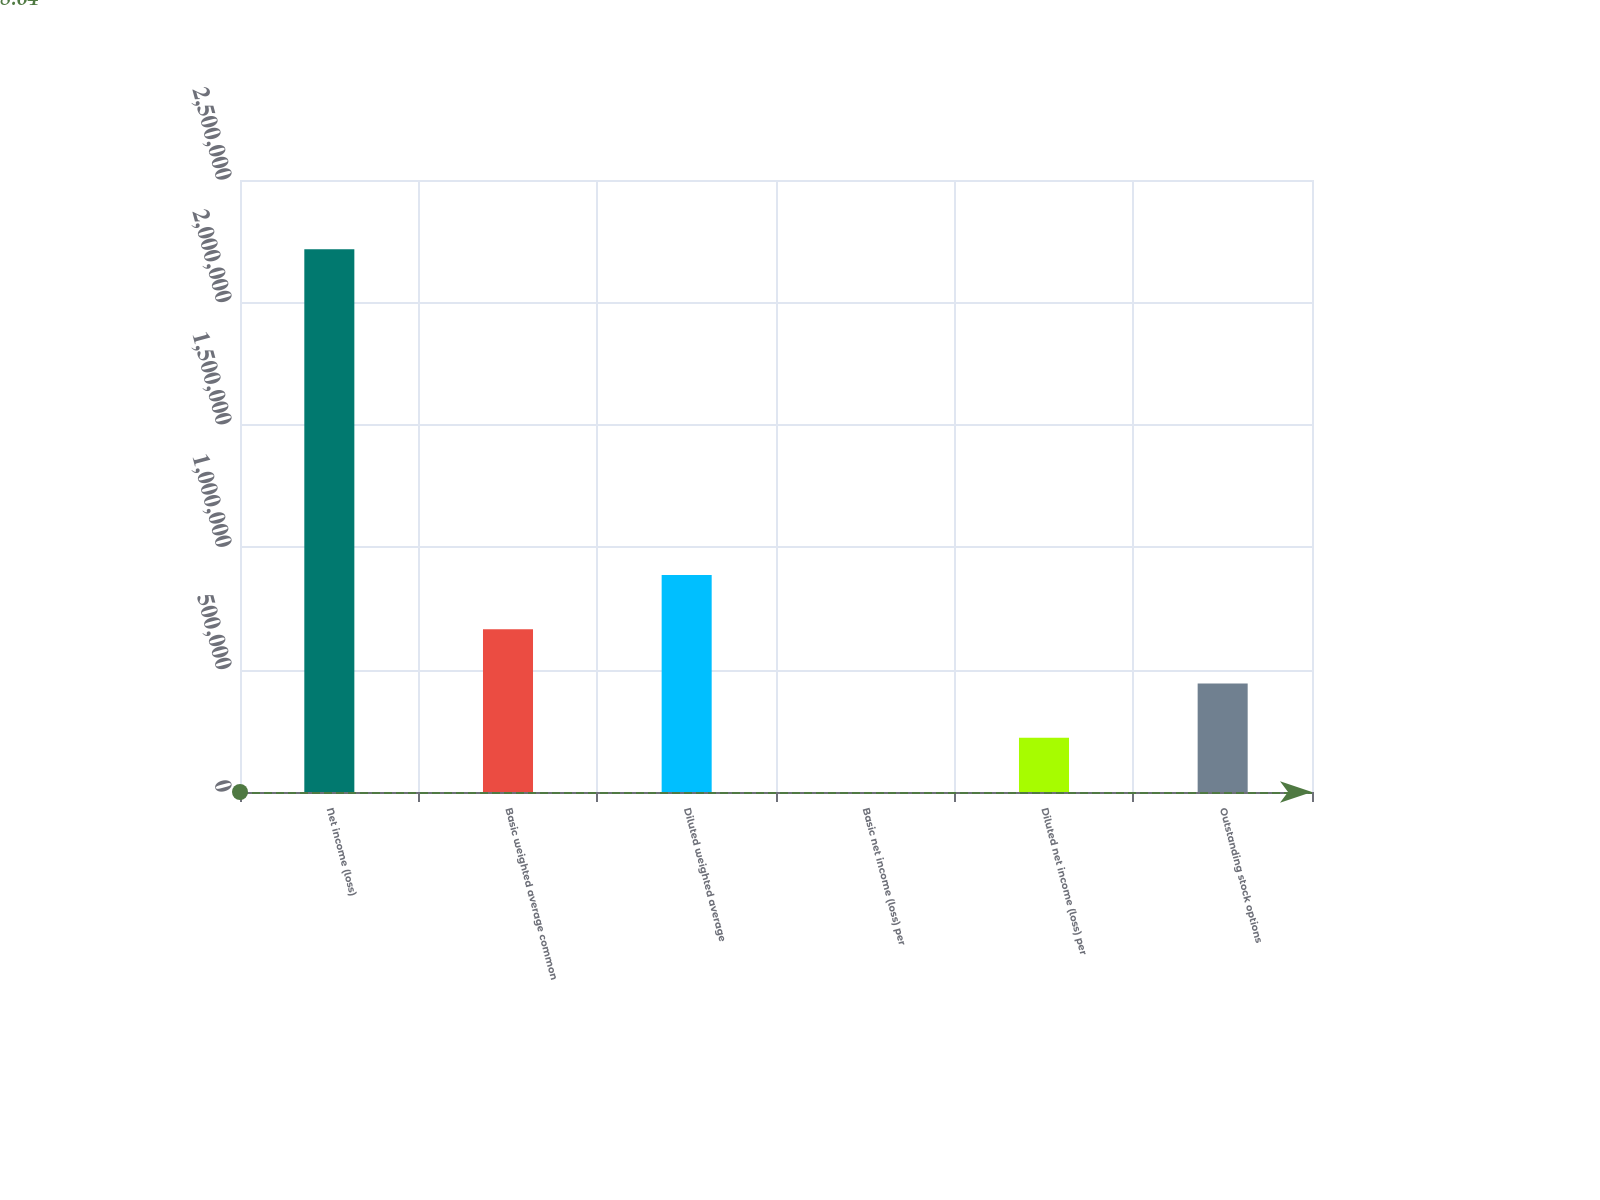Convert chart. <chart><loc_0><loc_0><loc_500><loc_500><bar_chart><fcel>Net income (loss)<fcel>Basic weighted average common<fcel>Diluted weighted average<fcel>Basic net income (loss) per<fcel>Diluted net income (loss) per<fcel>Outstanding stock options<nl><fcel>2.21664e+06<fcel>664999<fcel>886662<fcel>8.64<fcel>221672<fcel>443335<nl></chart> 